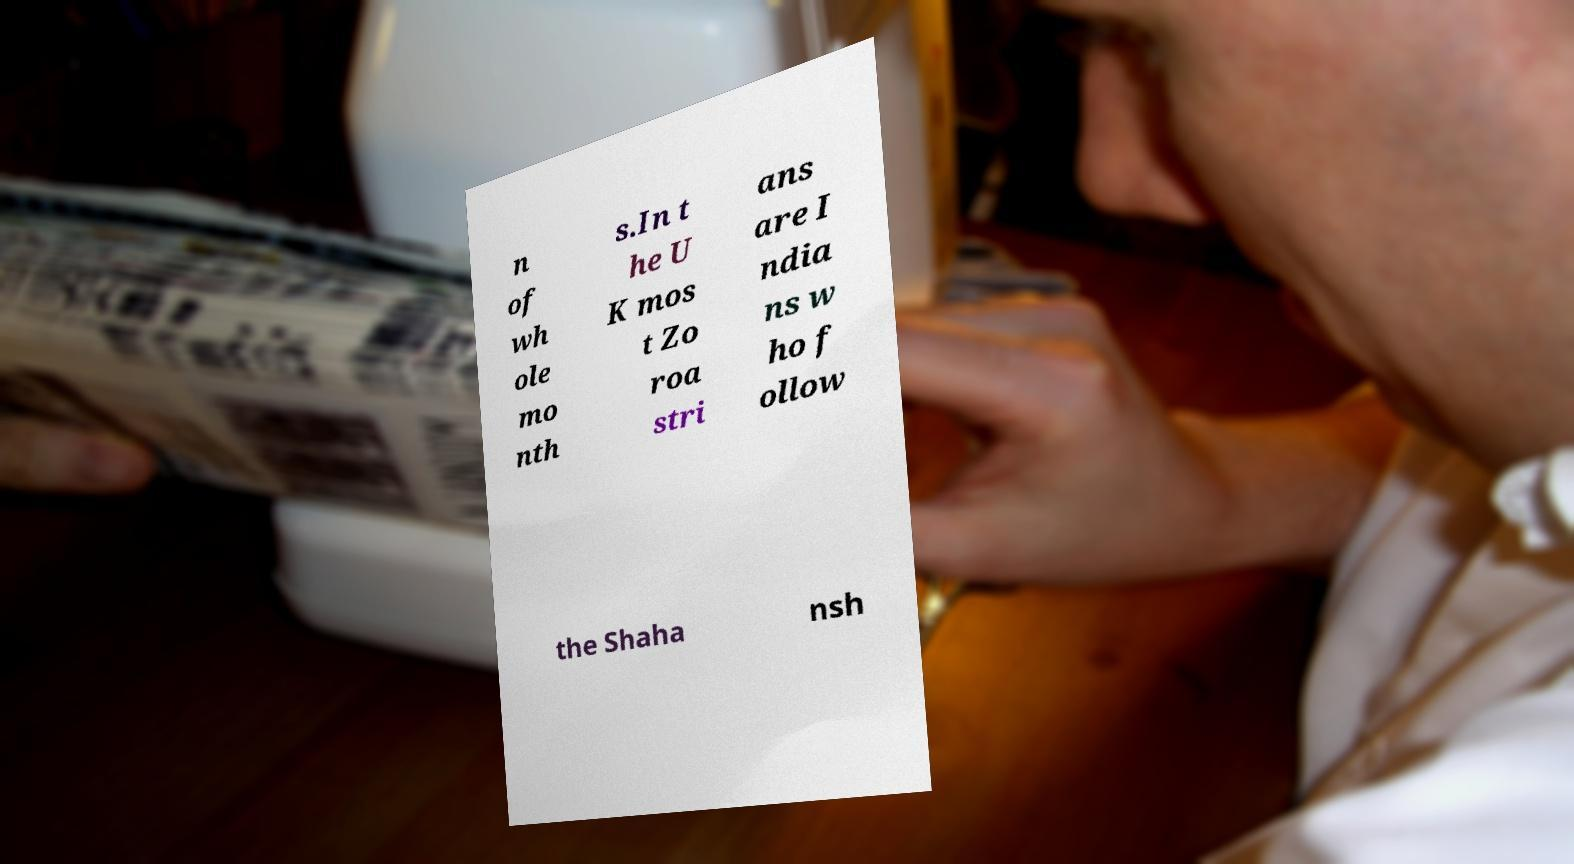Please identify and transcribe the text found in this image. n of wh ole mo nth s.In t he U K mos t Zo roa stri ans are I ndia ns w ho f ollow the Shaha nsh 